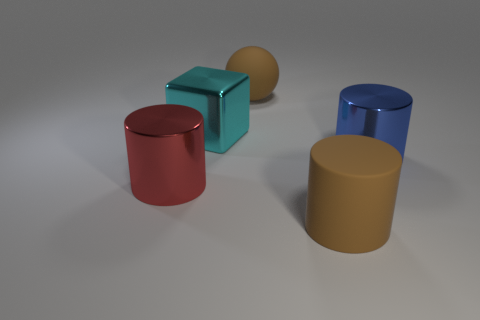Add 3 big spheres. How many objects exist? 8 Subtract all blocks. How many objects are left? 4 Subtract 1 blue cylinders. How many objects are left? 4 Subtract all red cylinders. Subtract all big metal blocks. How many objects are left? 3 Add 1 cylinders. How many cylinders are left? 4 Add 1 large metal things. How many large metal things exist? 4 